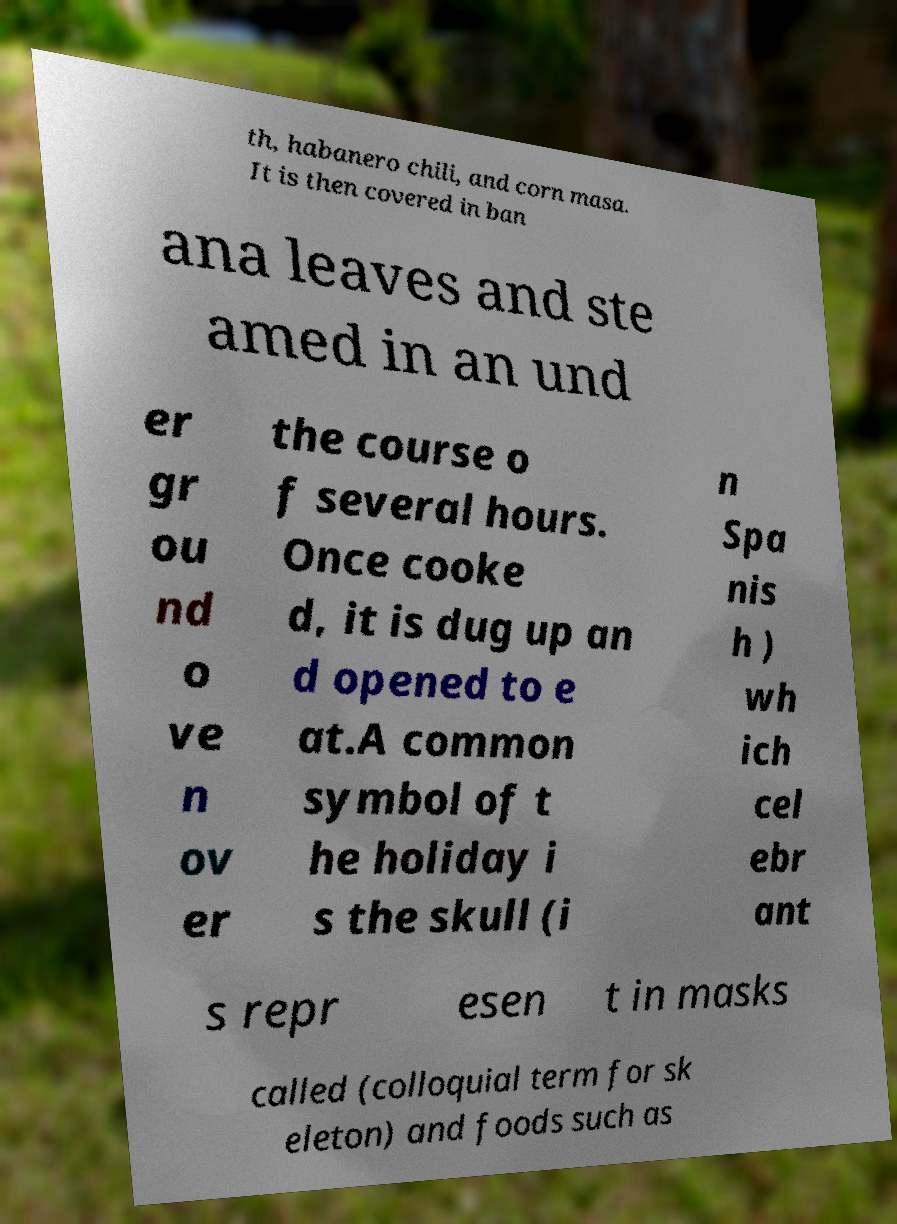Could you assist in decoding the text presented in this image and type it out clearly? th, habanero chili, and corn masa. It is then covered in ban ana leaves and ste amed in an und er gr ou nd o ve n ov er the course o f several hours. Once cooke d, it is dug up an d opened to e at.A common symbol of t he holiday i s the skull (i n Spa nis h ) wh ich cel ebr ant s repr esen t in masks called (colloquial term for sk eleton) and foods such as 